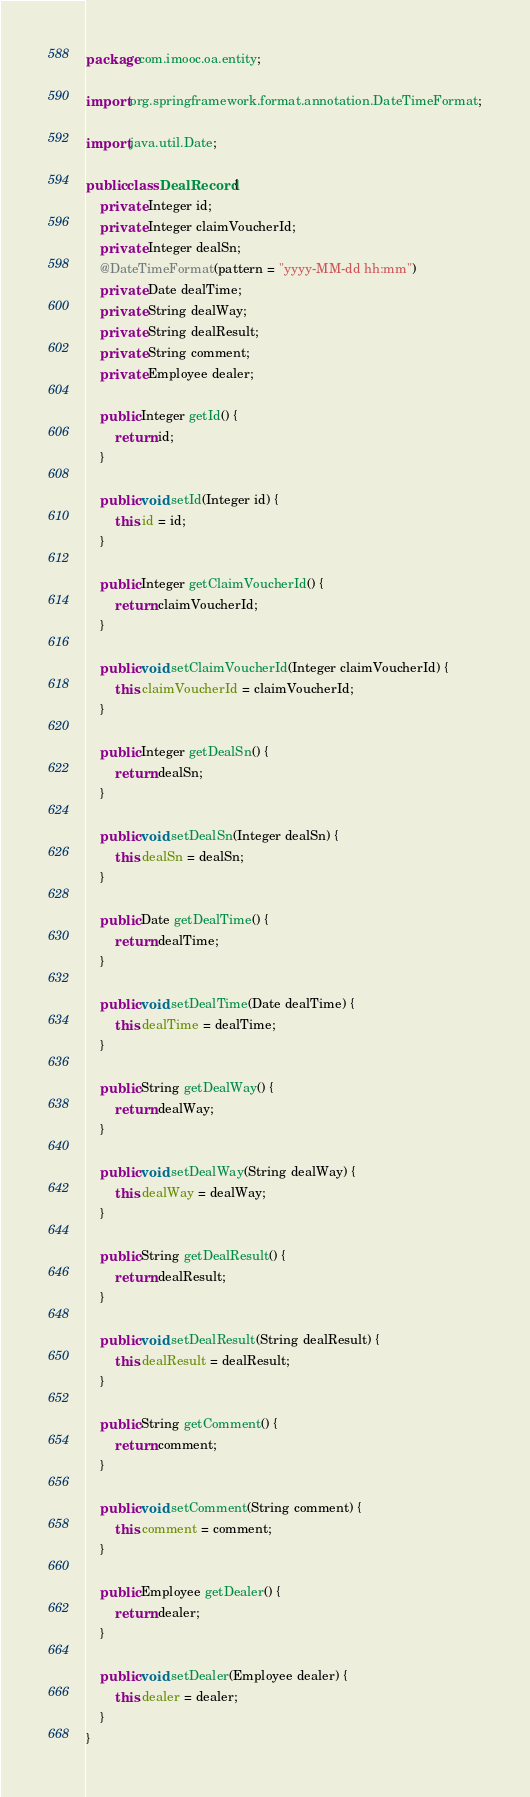Convert code to text. <code><loc_0><loc_0><loc_500><loc_500><_Java_>package com.imooc.oa.entity;

import org.springframework.format.annotation.DateTimeFormat;

import java.util.Date;

public class DealRecord {
    private Integer id;
    private Integer claimVoucherId;
    private Integer dealSn;
    @DateTimeFormat(pattern = "yyyy-MM-dd hh:mm")
    private Date dealTime;
    private String dealWay;
    private String dealResult;
    private String comment;
    private Employee dealer;

    public Integer getId() {
        return id;
    }

    public void setId(Integer id) {
        this.id = id;
    }

    public Integer getClaimVoucherId() {
        return claimVoucherId;
    }

    public void setClaimVoucherId(Integer claimVoucherId) {
        this.claimVoucherId = claimVoucherId;
    }

    public Integer getDealSn() {
        return dealSn;
    }

    public void setDealSn(Integer dealSn) {
        this.dealSn = dealSn;
    }

    public Date getDealTime() {
        return dealTime;
    }

    public void setDealTime(Date dealTime) {
        this.dealTime = dealTime;
    }

    public String getDealWay() {
        return dealWay;
    }

    public void setDealWay(String dealWay) {
        this.dealWay = dealWay;
    }

    public String getDealResult() {
        return dealResult;
    }

    public void setDealResult(String dealResult) {
        this.dealResult = dealResult;
    }

    public String getComment() {
        return comment;
    }

    public void setComment(String comment) {
        this.comment = comment;
    }

    public Employee getDealer() {
        return dealer;
    }

    public void setDealer(Employee dealer) {
        this.dealer = dealer;
    }
}</code> 